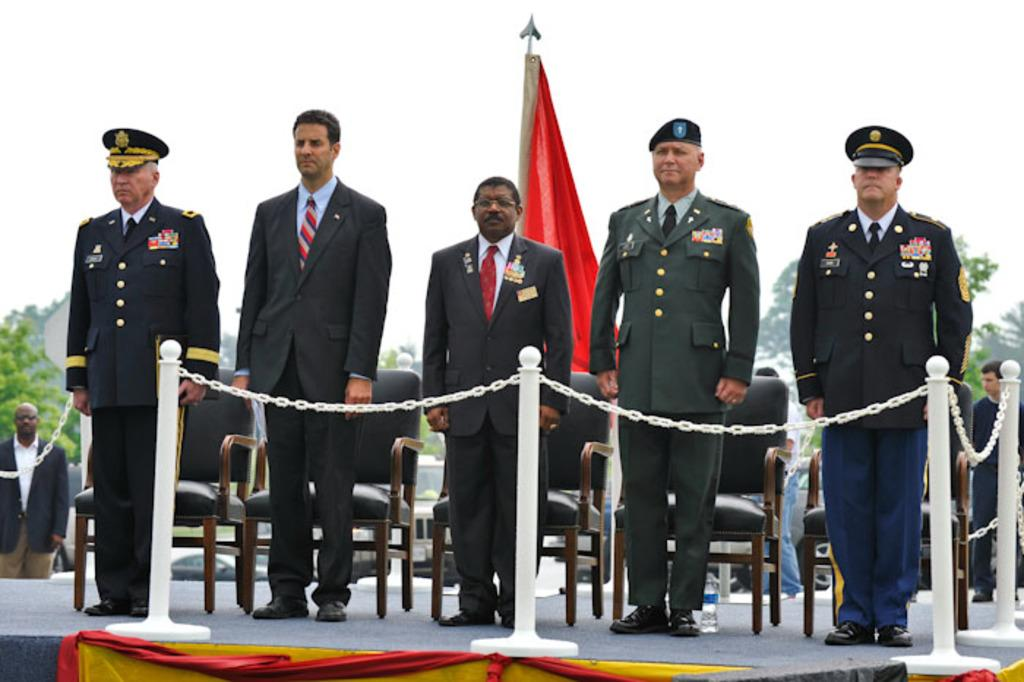What are the people in the image doing? The people are standing on the stage. What objects are in front of the people on the stage? There are rods with chains in front of the people. Can you describe any furniture in the image? Yes, there are chairs in the image. What can be seen in the background of the image? Trees and the sky are visible in the background. Can you provide an example of a plastic item in the image? There is no plastic item present in the image. What request are the people on the stage making to the audience? The image does not provide any information about a request being made by the people on the stage. 